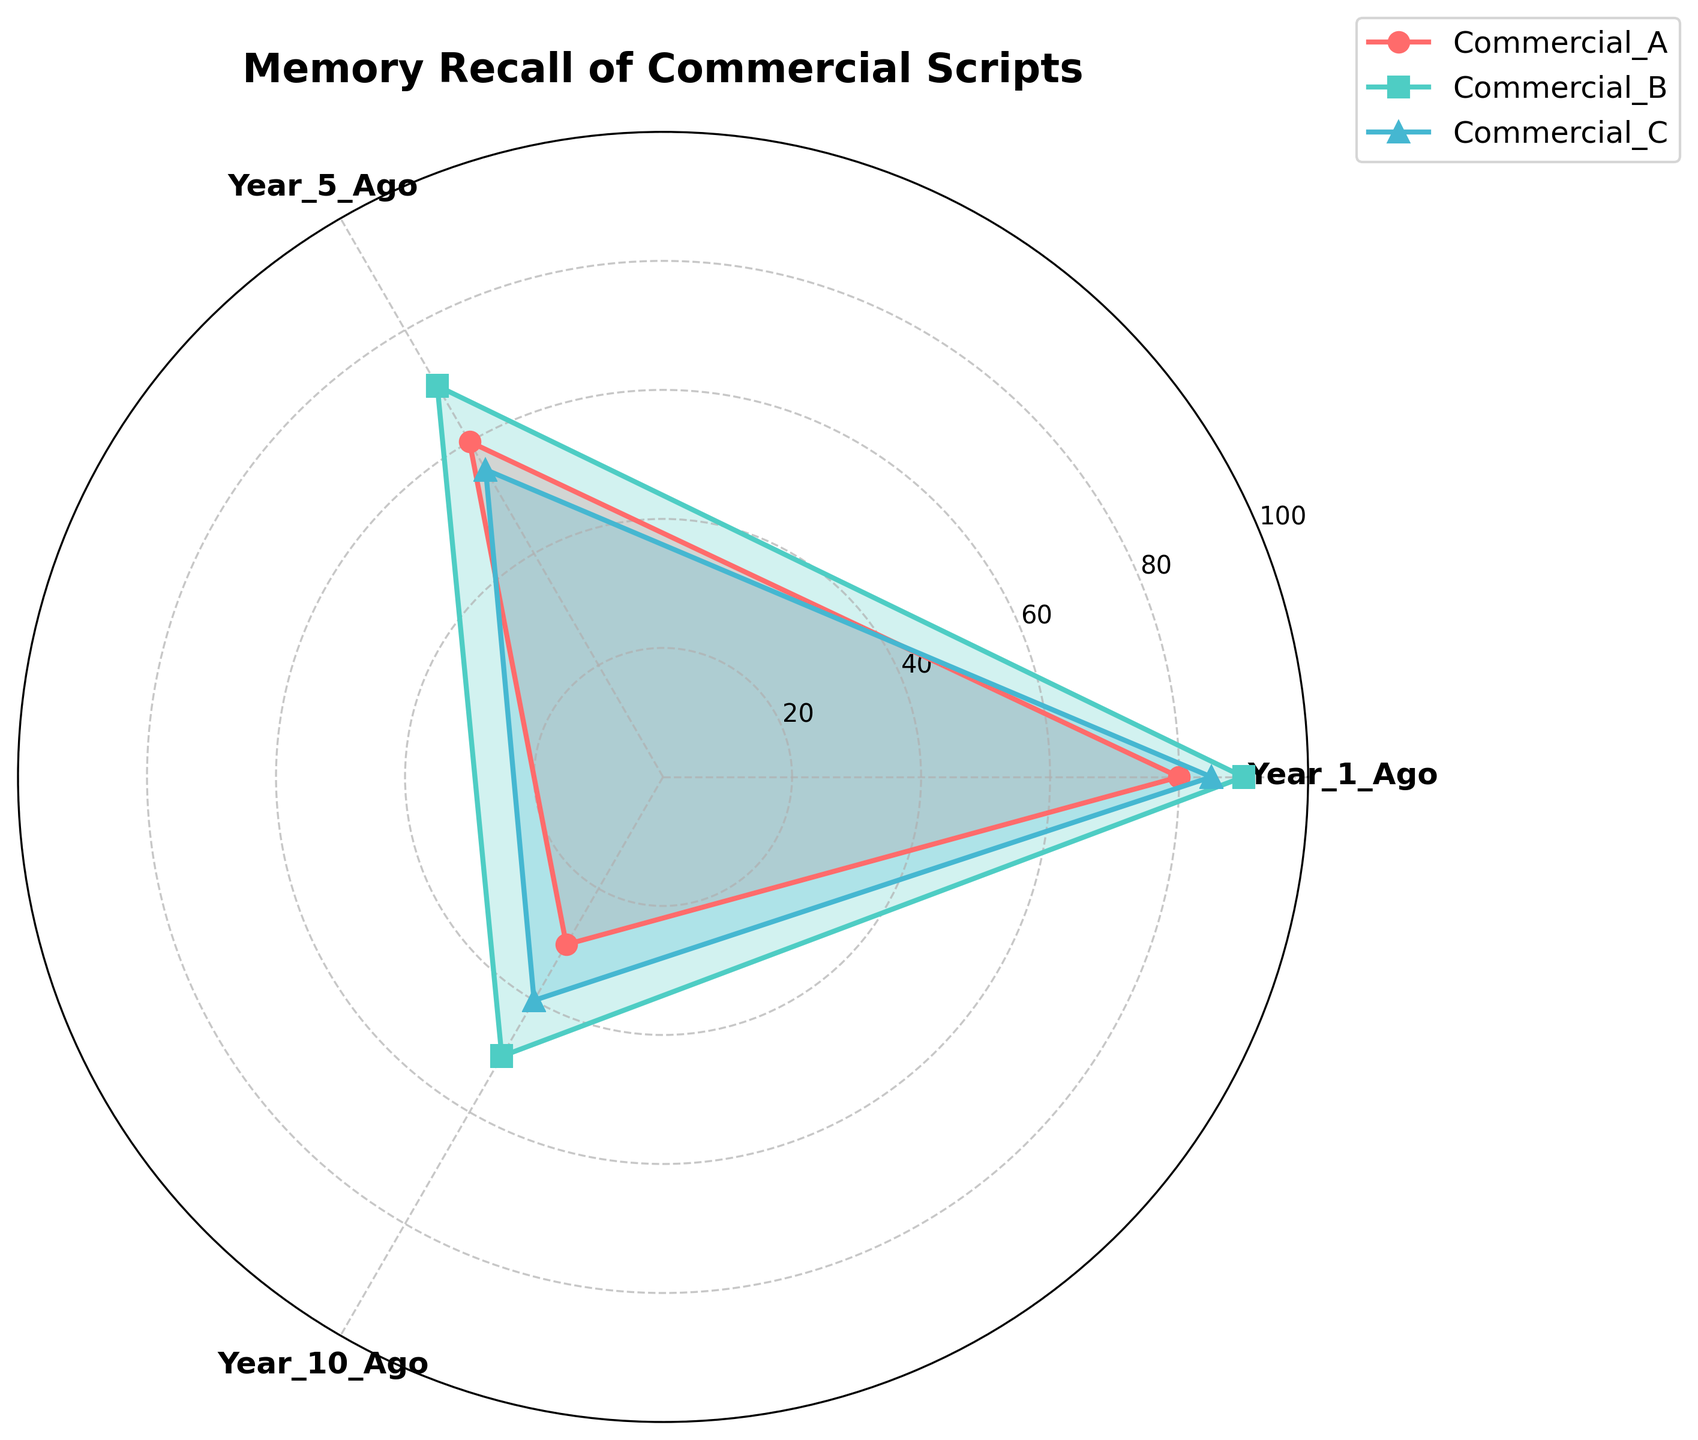Which commercial has the highest memory recall for scripts from 1 year ago? The figure shows different values for memory recall of commercial scripts. By looking at the segment corresponding to 1 Year Ago, we see that Commercial B has the highest value.
Answer: Commercial B Which commercial has the lowest memory recall for scripts from 10 years ago? The filled areas on the radar chart indicate memory recall values. For the Year_10_Ago category, Commercial A shows the lowest value.
Answer: Commercial A What is the average memory recall value for Commercial C across all years? For Commercial C, the memory recall values are 85, 55, and 40 for 1 year, 5 years, and 10 years ago, respectively. The average is calculated as (85 + 55 + 40) / 3.
Answer: 60 How does the memory recall for Commercial A from 5 years ago compare to that of 10 years ago? The memory recall values for Commercial A are 60 for 5 years ago and 30 for 10 years ago. Therefore, the value for 5 years ago is higher.
Answer: Higher Which category (year) shows the most variation in memory recall among the commercials? By comparing the spread of the values for each category, the Year_10_Ago category exhibits the widest range between the highest and lowest values (50 - 30 = 20).
Answer: Year_10_Ago What is the sum of memory recall values for Commercial B across all years? The memory recall values for Commercial B are 90, 70, and 50 for 1 year, 5 years, and 10 years ago, respectively. The sum is calculated as 90 + 70 + 50.
Answer: 210 Is there any category where all commercials have memory recall values above 50? By examining each category visually, the Year_1_Ago category is the only one where all values (80, 90, 85) are above 50.
Answer: Yes Which commercial has the most consistent memory recall across all years? Consistency can be analyzed by observing the uniformity of the values. Commercial B has values 90, 70, and 50, which are closer in range compared to other commercials.
Answer: Commercial B In which year did Commercial A have the greatest drop in memory recall compared to the previous interval? The largest drop for Commercial A can be observed from 1 year ago (80) to 5 years ago (60), which is a difference of 20, and from 5 years ago (60) to 10 years ago (30), which is a drop of 30. Hence, the largest drop is from 5 years ago to 10 years ago.
Answer: From 5 years ago to 10 years ago 